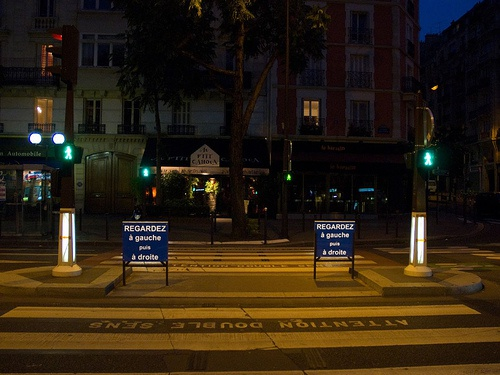Describe the objects in this image and their specific colors. I can see traffic light in black, maroon, and brown tones, traffic light in black, teal, white, and darkgreen tones, traffic light in black, darkgreen, and white tones, traffic light in black, maroon, and brown tones, and traffic light in black, teal, and white tones in this image. 